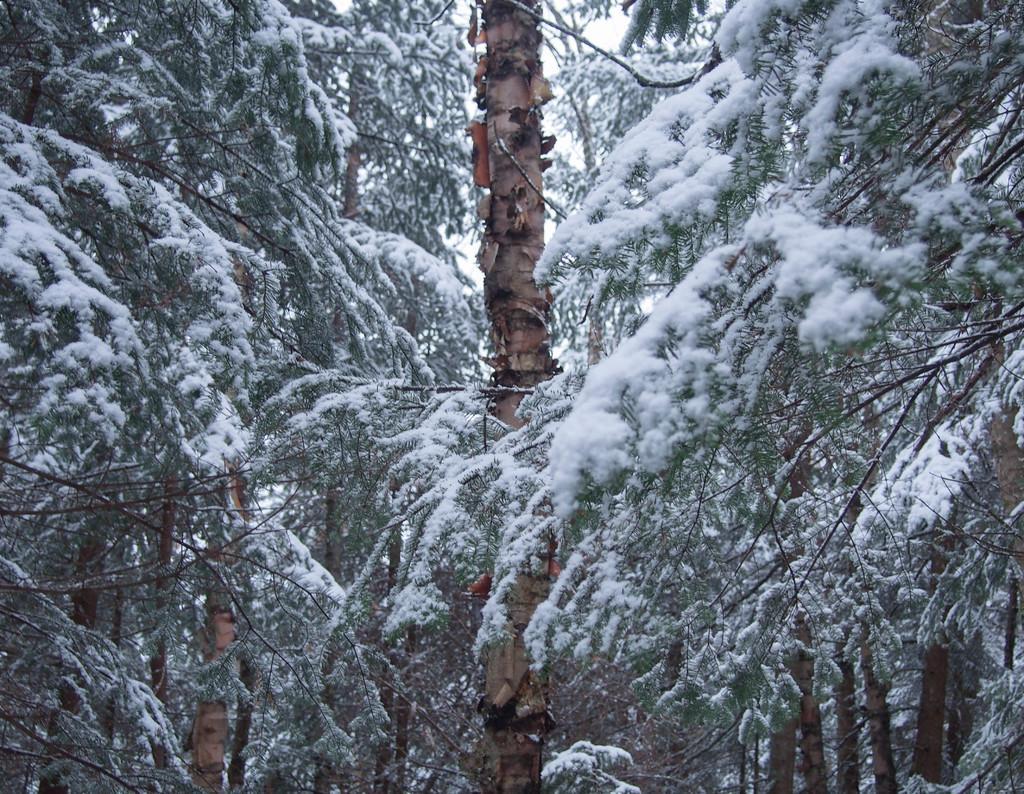Can you describe this image briefly? In this image, there are trees with the snow. 